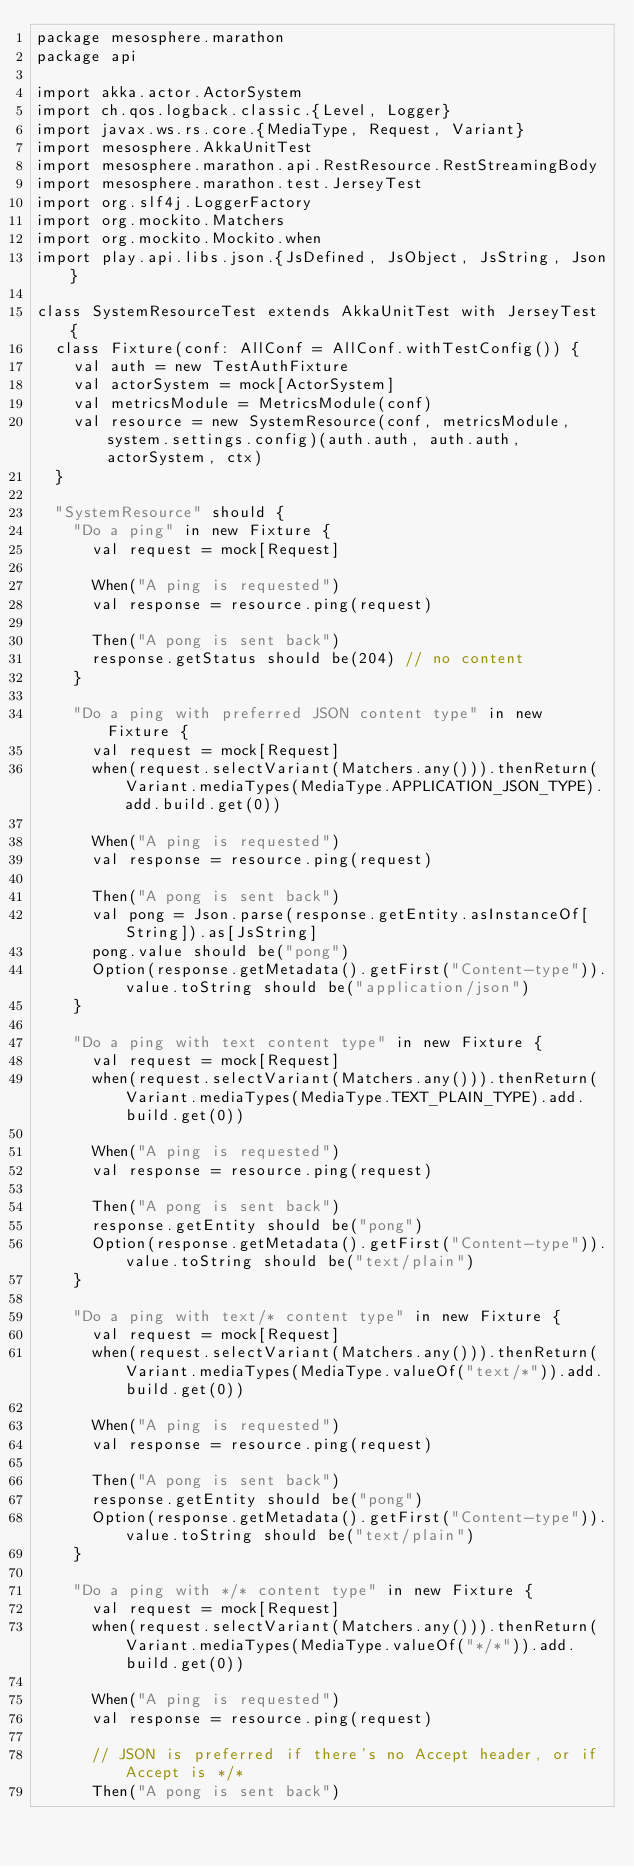<code> <loc_0><loc_0><loc_500><loc_500><_Scala_>package mesosphere.marathon
package api

import akka.actor.ActorSystem
import ch.qos.logback.classic.{Level, Logger}
import javax.ws.rs.core.{MediaType, Request, Variant}
import mesosphere.AkkaUnitTest
import mesosphere.marathon.api.RestResource.RestStreamingBody
import mesosphere.marathon.test.JerseyTest
import org.slf4j.LoggerFactory
import org.mockito.Matchers
import org.mockito.Mockito.when
import play.api.libs.json.{JsDefined, JsObject, JsString, Json}

class SystemResourceTest extends AkkaUnitTest with JerseyTest {
  class Fixture(conf: AllConf = AllConf.withTestConfig()) {
    val auth = new TestAuthFixture
    val actorSystem = mock[ActorSystem]
    val metricsModule = MetricsModule(conf)
    val resource = new SystemResource(conf, metricsModule, system.settings.config)(auth.auth, auth.auth, actorSystem, ctx)
  }

  "SystemResource" should {
    "Do a ping" in new Fixture {
      val request = mock[Request]

      When("A ping is requested")
      val response = resource.ping(request)

      Then("A pong is sent back")
      response.getStatus should be(204) // no content
    }

    "Do a ping with preferred JSON content type" in new Fixture {
      val request = mock[Request]
      when(request.selectVariant(Matchers.any())).thenReturn(Variant.mediaTypes(MediaType.APPLICATION_JSON_TYPE).add.build.get(0))

      When("A ping is requested")
      val response = resource.ping(request)

      Then("A pong is sent back")
      val pong = Json.parse(response.getEntity.asInstanceOf[String]).as[JsString]
      pong.value should be("pong")
      Option(response.getMetadata().getFirst("Content-type")).value.toString should be("application/json")
    }

    "Do a ping with text content type" in new Fixture {
      val request = mock[Request]
      when(request.selectVariant(Matchers.any())).thenReturn(Variant.mediaTypes(MediaType.TEXT_PLAIN_TYPE).add.build.get(0))

      When("A ping is requested")
      val response = resource.ping(request)

      Then("A pong is sent back")
      response.getEntity should be("pong")
      Option(response.getMetadata().getFirst("Content-type")).value.toString should be("text/plain")
    }

    "Do a ping with text/* content type" in new Fixture {
      val request = mock[Request]
      when(request.selectVariant(Matchers.any())).thenReturn(Variant.mediaTypes(MediaType.valueOf("text/*")).add.build.get(0))

      When("A ping is requested")
      val response = resource.ping(request)

      Then("A pong is sent back")
      response.getEntity should be("pong")
      Option(response.getMetadata().getFirst("Content-type")).value.toString should be("text/plain")
    }

    "Do a ping with */* content type" in new Fixture {
      val request = mock[Request]
      when(request.selectVariant(Matchers.any())).thenReturn(Variant.mediaTypes(MediaType.valueOf("*/*")).add.build.get(0))

      When("A ping is requested")
      val response = resource.ping(request)

      // JSON is preferred if there's no Accept header, or if Accept is */*
      Then("A pong is sent back")</code> 